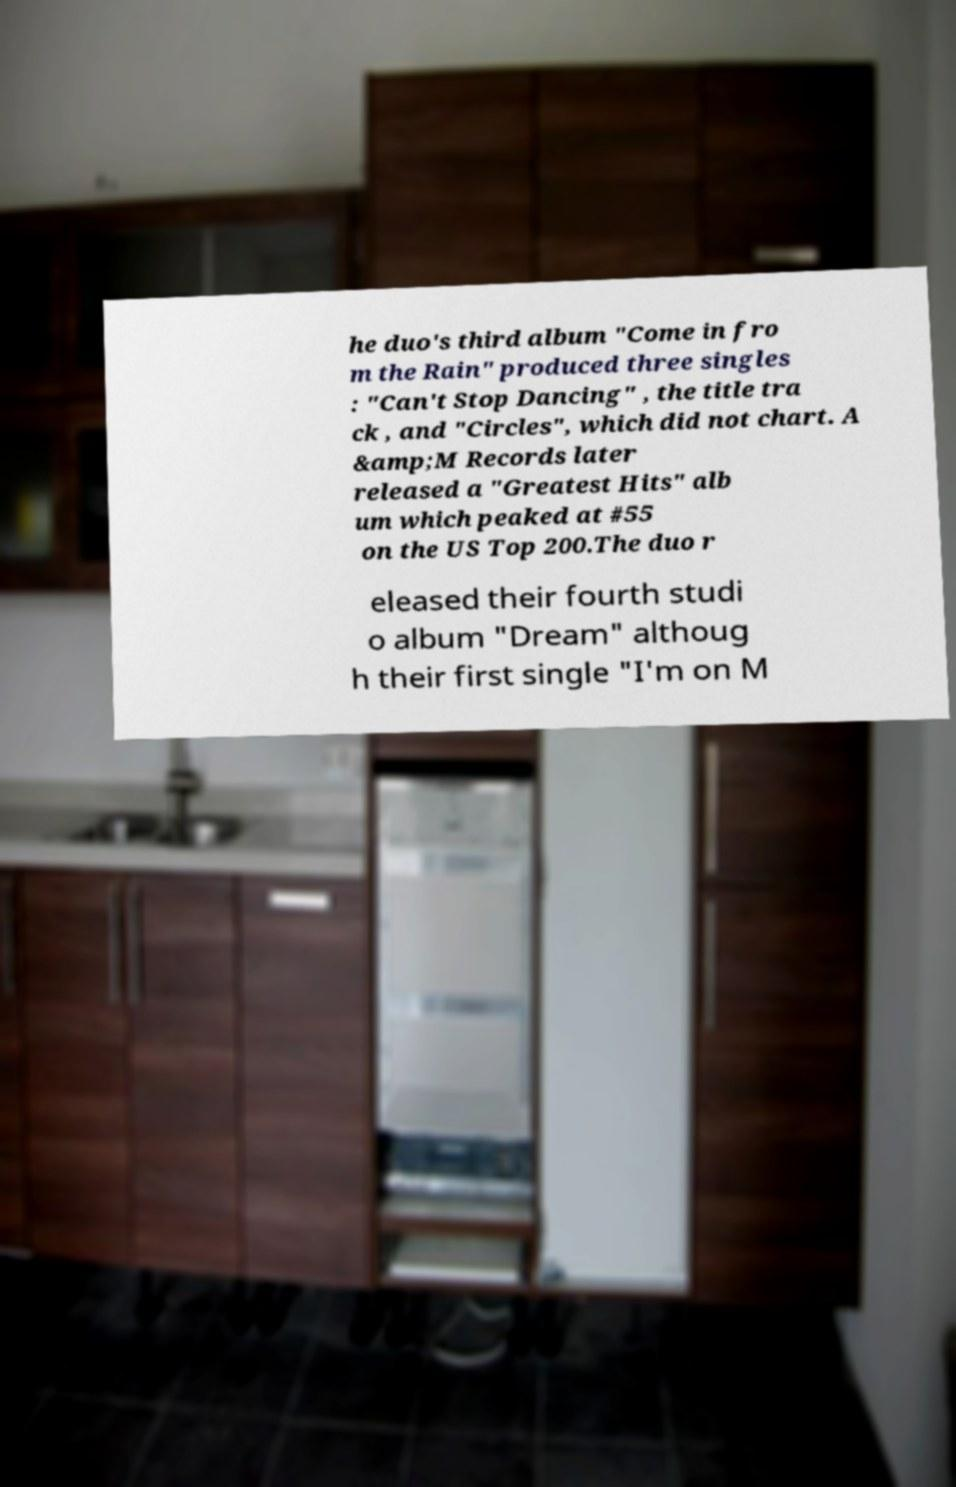Could you extract and type out the text from this image? he duo's third album "Come in fro m the Rain" produced three singles : "Can't Stop Dancing" , the title tra ck , and "Circles", which did not chart. A &amp;M Records later released a "Greatest Hits" alb um which peaked at #55 on the US Top 200.The duo r eleased their fourth studi o album "Dream" althoug h their first single "I'm on M 